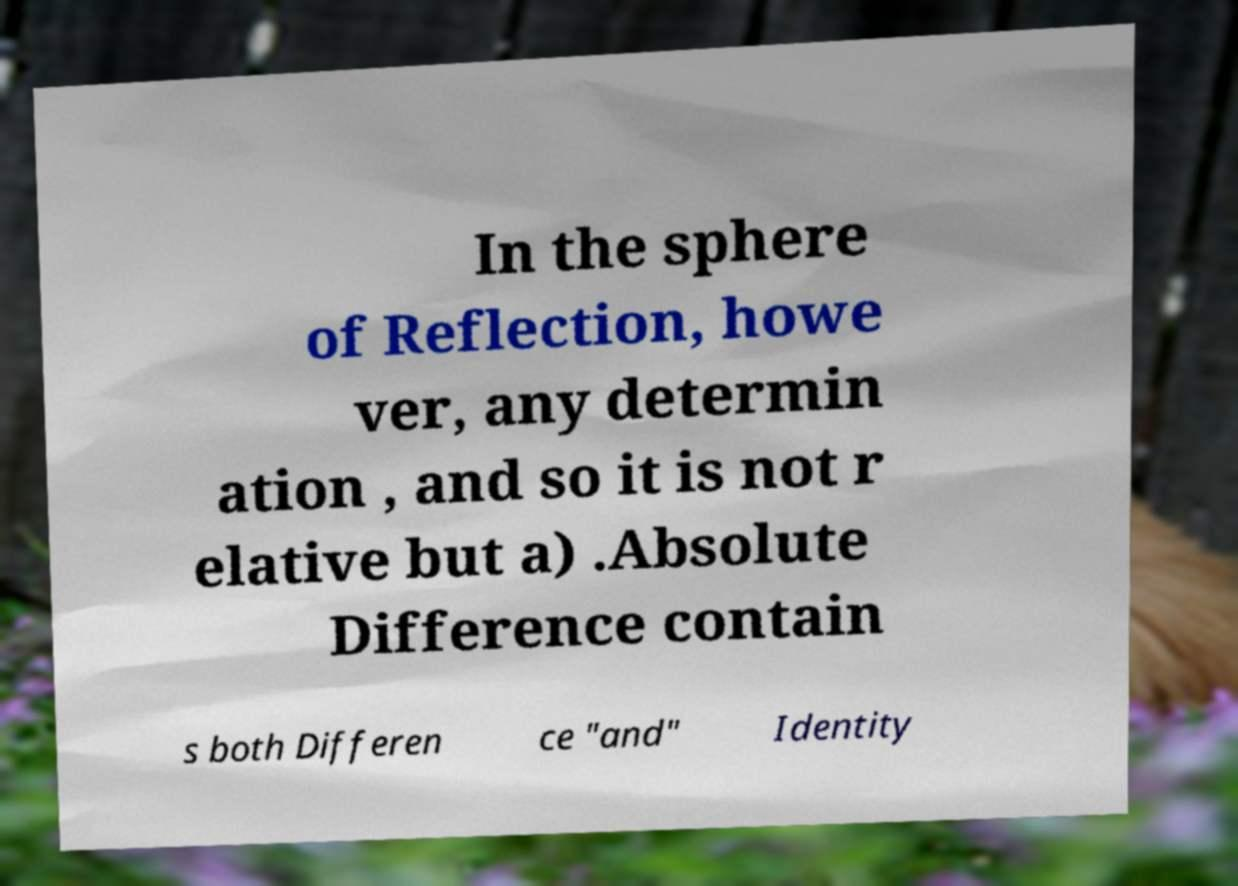Please identify and transcribe the text found in this image. In the sphere of Reflection, howe ver, any determin ation , and so it is not r elative but a) .Absolute Difference contain s both Differen ce "and" Identity 